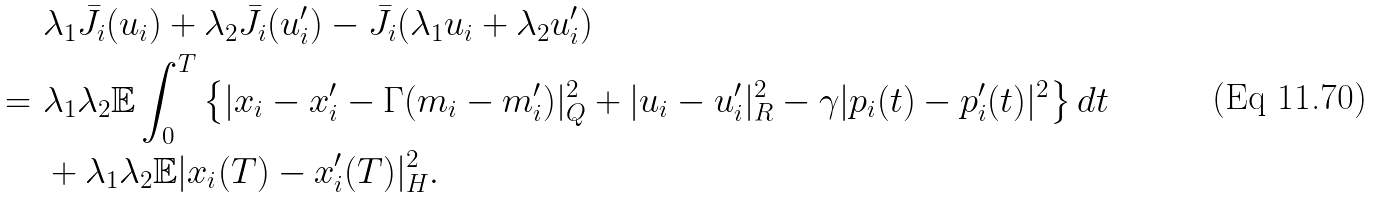Convert formula to latex. <formula><loc_0><loc_0><loc_500><loc_500>& \lambda _ { 1 } \bar { J } _ { i } ( u _ { i } ) + \lambda _ { 2 } \bar { J } _ { i } ( u _ { i } ^ { \prime } ) - \bar { J } _ { i } ( \lambda _ { 1 } u _ { i } + \lambda _ { 2 } u _ { i } ^ { \prime } ) \\ = \ & \lambda _ { 1 } \lambda _ { 2 } \mathbb { E } \int _ { 0 } ^ { T } \left \{ | x _ { i } - x _ { i } ^ { \prime } - \Gamma ( m _ { i } - m _ { i } ^ { \prime } ) | _ { Q } ^ { 2 } + | u _ { i } - u _ { i } ^ { \prime } | _ { R } ^ { 2 } - \gamma | p _ { i } ( t ) - p _ { i } ^ { \prime } ( t ) | ^ { 2 } \right \} d t \\ & + \lambda _ { 1 } \lambda _ { 2 } \mathbb { E } | x _ { i } ( T ) - x _ { i } ^ { \prime } ( T ) | _ { H } ^ { 2 } .</formula> 